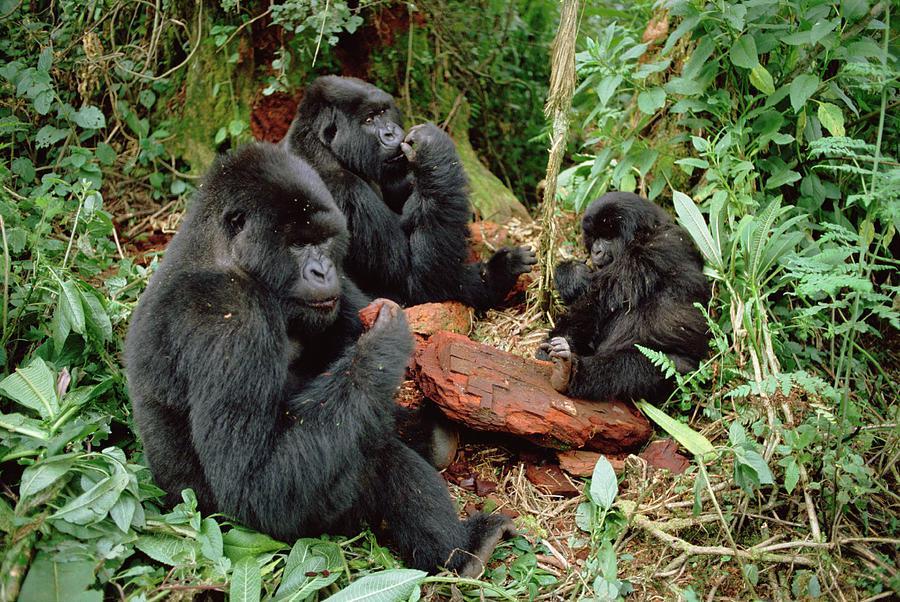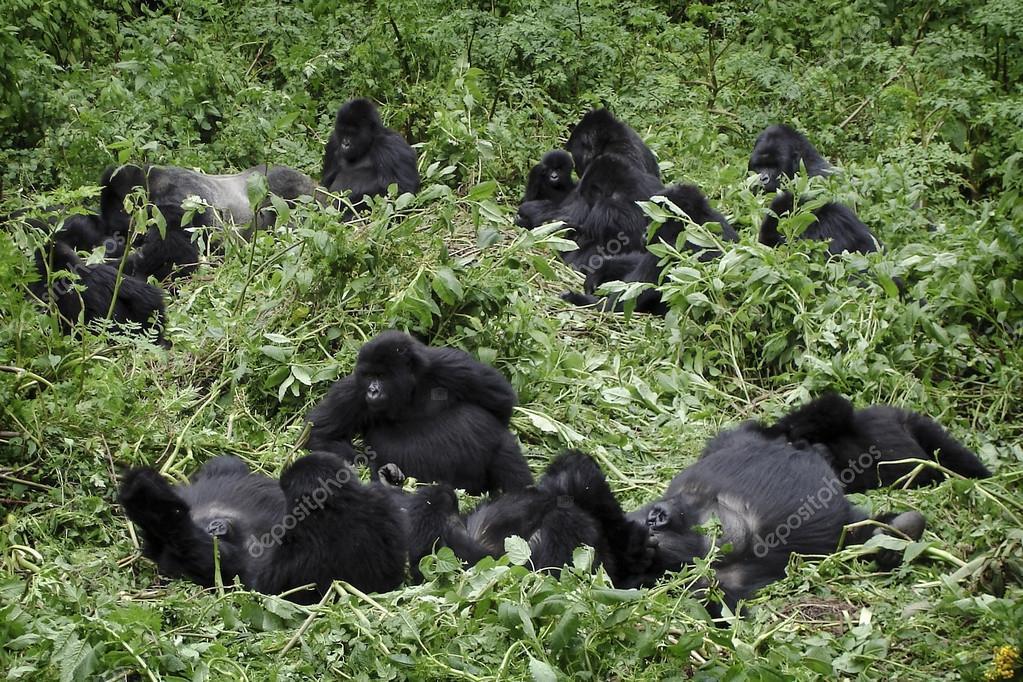The first image is the image on the left, the second image is the image on the right. For the images shown, is this caption "There are at least 6 gorillas in the right image." true? Answer yes or no. Yes. The first image is the image on the left, the second image is the image on the right. Evaluate the accuracy of this statement regarding the images: "There are no more than five gorillas.". Is it true? Answer yes or no. No. 